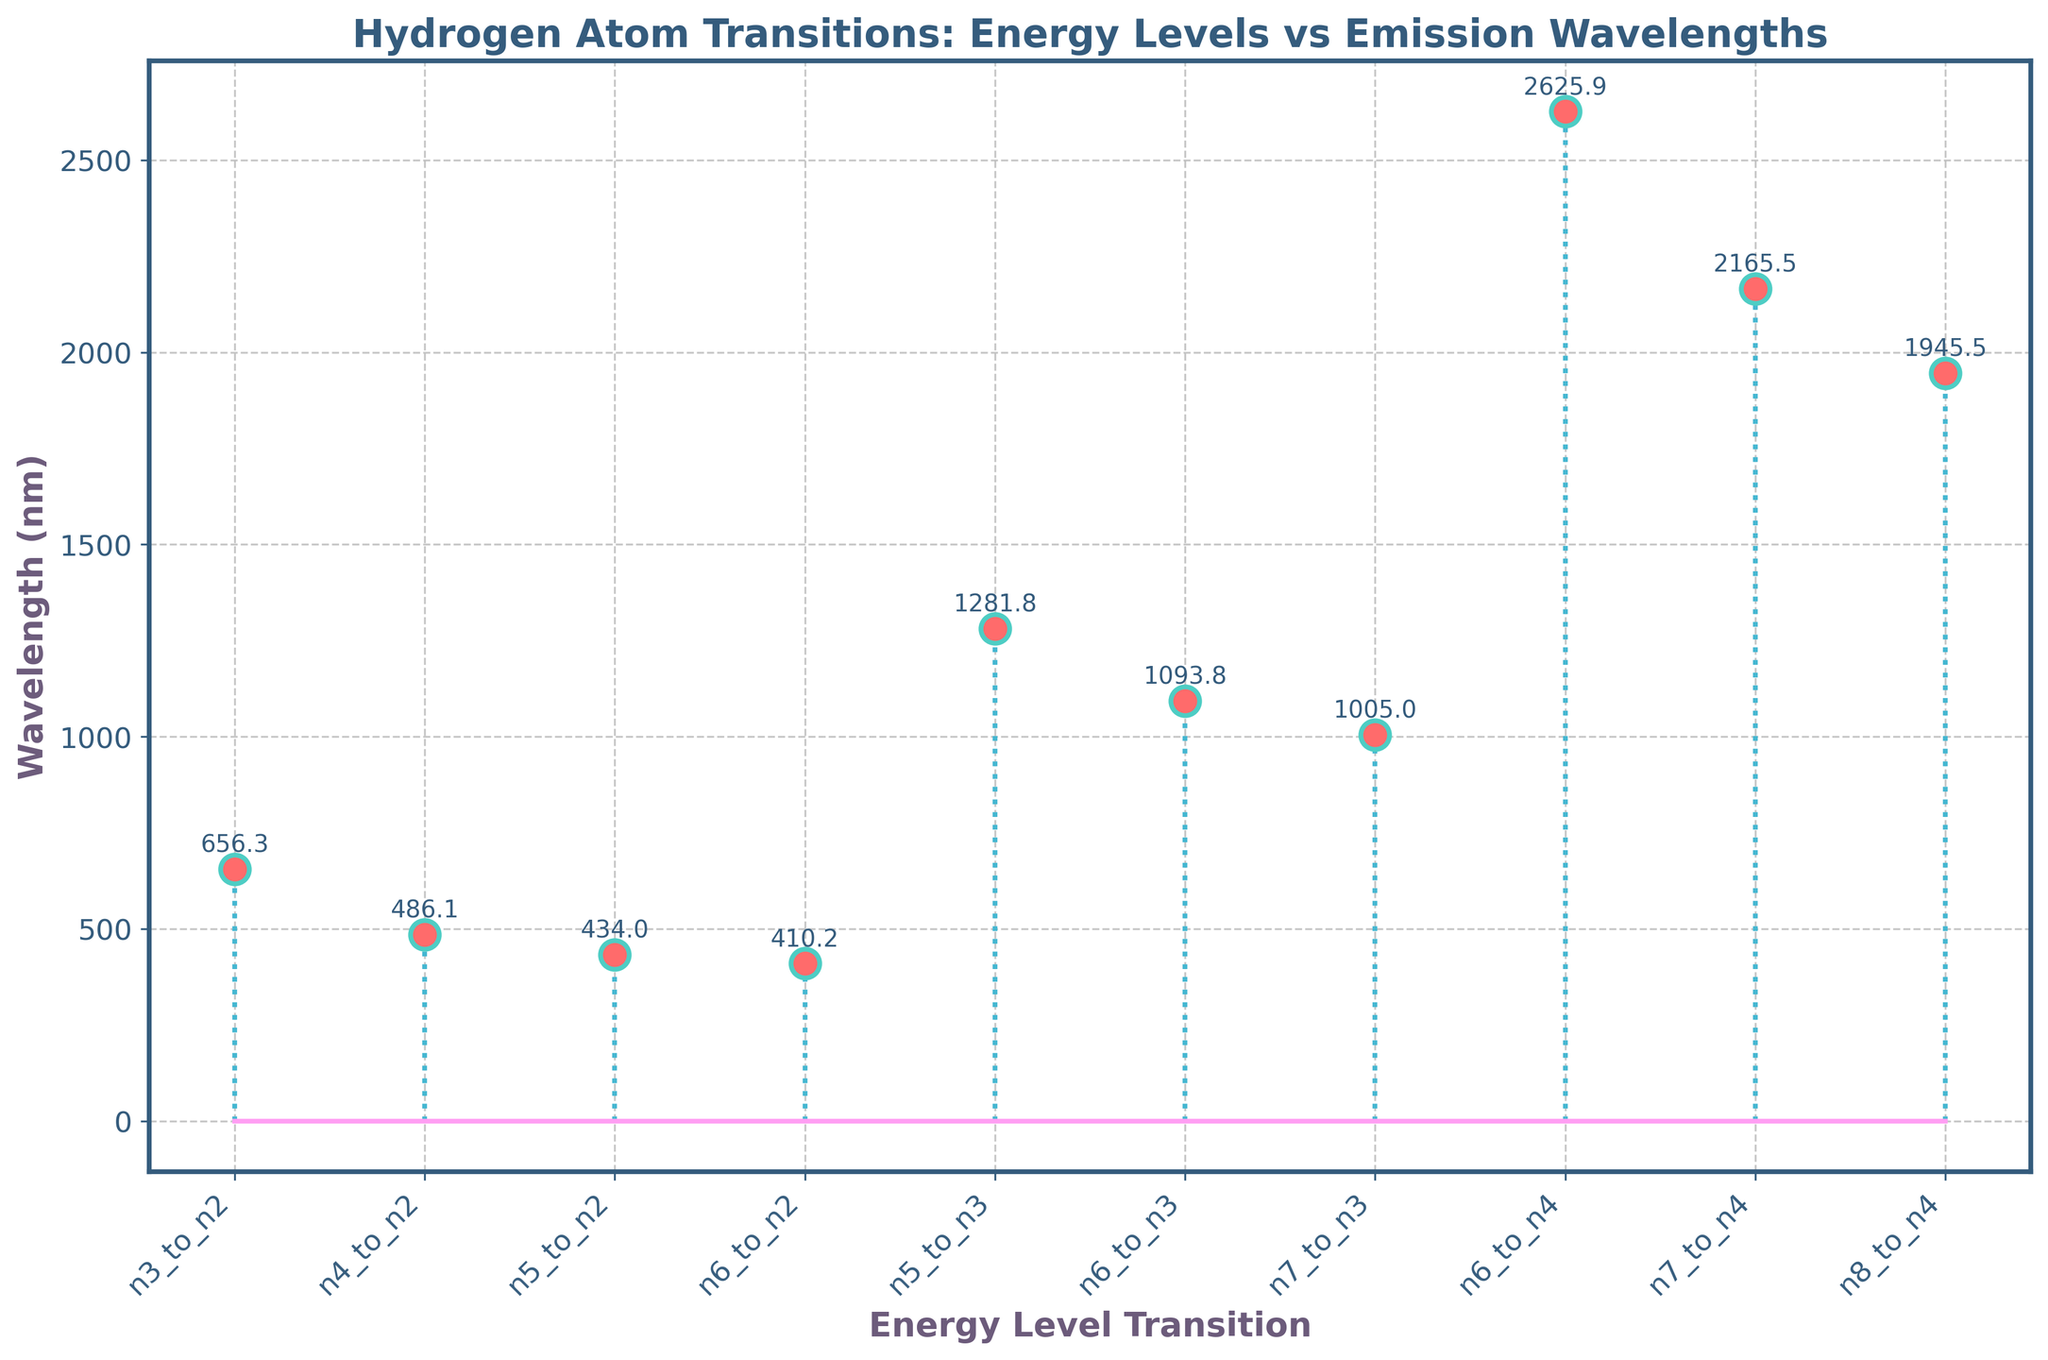What is the title of the plot? The title of the plot is usually found at the top and is in bold to make it easily noticeable. In this figure, the title reads "Hydrogen Atom Transitions: Energy Levels vs Emission Wavelengths" and is colored in a distinct font color.
Answer: Hydrogen Atom Transitions: Energy Levels vs Emission Wavelengths How many transitions are represented in the plot? To determine the number of transitions, count the number of marker points or the number of x-axis labels corresponding to each transition. There are 10 distinct labels on the x-axis, representing 10 transitions.
Answer: 10 Which transition has the highest emission wavelength? To find the transition with the highest emission wavelength, look for the marker point that is placed highest on the y-axis. The transition "n6_to_n4" is the highest and annotated with the value 2625.9 nm.
Answer: n6_to_n4 Which transition has the lowest emission wavelength? To identify the transition with the lowest emission wavelength, check for the marker point placed lowest on the y-axis. The transition "n8_to_n4" is the lowest and annotated with the value 1945.5 nm.
Answer: n8_to_n4 What is the median wavelength of all the transitions? To find the median, list all the emission wavelengths and sort them in ascending order: 410.2, 434.0, 486.1, 656.3, 1005.0, 1093.8, 1281.8, 1945.5, 2165.5, 2625.9. Since there are 10 data points, the median will be the average of the 5th and 6th values: (1005.0 + 1093.8) / 2 = 1049.4 nm.
Answer: 1049.4 nm What is the average wavelength of the transitions involving level n3? First, find all transitions that involve level n3: "n5_to_n3", "n6_to_n3", and "n7_to_n3". Their wavelengths are 1281.8 nm, 1093.8 nm, and 1005.0 nm. Calculate the average: (1281.8 + 1093.8 + 1005.0) / 3 = 1126.87 nm.
Answer: 1126.87 nm Which transitions are longer than 1000 nm? Look for marker points above the 1000 nm mark on the y-axis. The transitions "n5_to_n3", "n6_to_n3", "n7_to_n3", "n6_to_n4", "n7_to_n4", and "n8_to_n4" have wavelengths annotated as 1281.8 nm, 1093.8 nm, 1005.0 nm, 2625.9 nm, 2165.5 nm, and 1945.5 nm, respectively.
Answer: n5_to_n3, n6_to_n3, n7_to_n3, n6_to_n4, n7_to_n4, n8_to_n4 What color are the markers and lines in the plot? Observing the plot, the markers are colored a shade of red and have cyan edges, while the stems (lines) are light blue.
Answer: Red markers with cyan edges and light blue lines Which transition shows a wavelength closest to 500 nm? Look at the marker points near the 500 nm mark on the y-axis. The transition "n4_to_n2" is annotated with 486.1 nm, which is closest to 500 nm among all displayed transitions.
Answer: n4_to_n2 